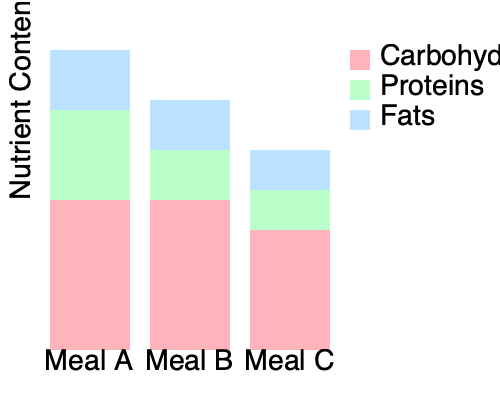Analyze the stacked bar chart representing the nutrient composition of three meals (A, B, and C). Which meal has the highest protein-to-carbohydrate ratio, and what is this ratio? To solve this problem, we need to follow these steps:

1. Identify the nutrient components in each bar:
   - Pink (top): Carbohydrates
   - Green (middle): Proteins
   - Blue (bottom): Fats

2. Estimate the relative heights of protein and carbohydrate portions for each meal:

   Meal A:
   - Proteins: 90 units
   - Carbohydrates: 150 units

   Meal B:
   - Proteins: 50 units
   - Carbohydrates: 150 units

   Meal C:
   - Proteins: 40 units
   - Carbohydrates: 120 units

3. Calculate the protein-to-carbohydrate ratio for each meal:

   Meal A: $\frac{90}{150} = 0.6$
   Meal B: $\frac{50}{150} = 0.33$
   Meal C: $\frac{40}{120} = 0.33$

4. Compare the ratios to find the highest:
   Meal A has the highest ratio at 0.6

Therefore, Meal A has the highest protein-to-carbohydrate ratio of 0.6 or 3:5.
Answer: Meal A, with a protein-to-carbohydrate ratio of 0.6 (or 3:5). 